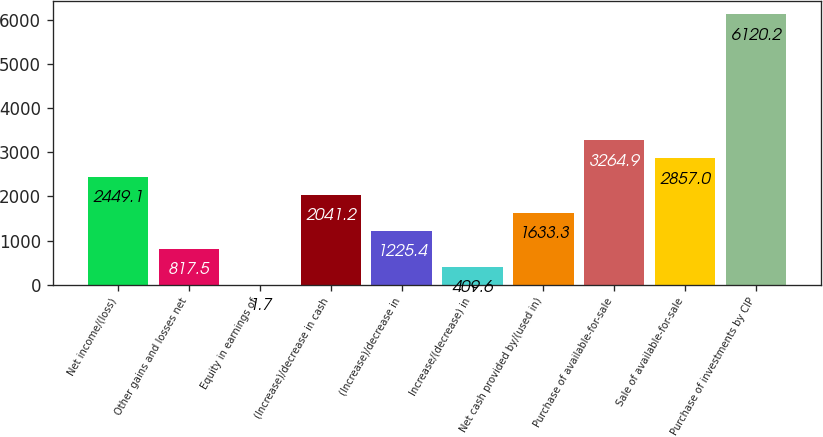Convert chart. <chart><loc_0><loc_0><loc_500><loc_500><bar_chart><fcel>Net income/(loss)<fcel>Other gains and losses net<fcel>Equity in earnings of<fcel>(Increase)/decrease in cash<fcel>(Increase)/decrease in<fcel>Increase/(decrease) in<fcel>Net cash provided by/(used in)<fcel>Purchase of available-for-sale<fcel>Sale of available-for-sale<fcel>Purchase of investments by CIP<nl><fcel>2449.1<fcel>817.5<fcel>1.7<fcel>2041.2<fcel>1225.4<fcel>409.6<fcel>1633.3<fcel>3264.9<fcel>2857<fcel>6120.2<nl></chart> 